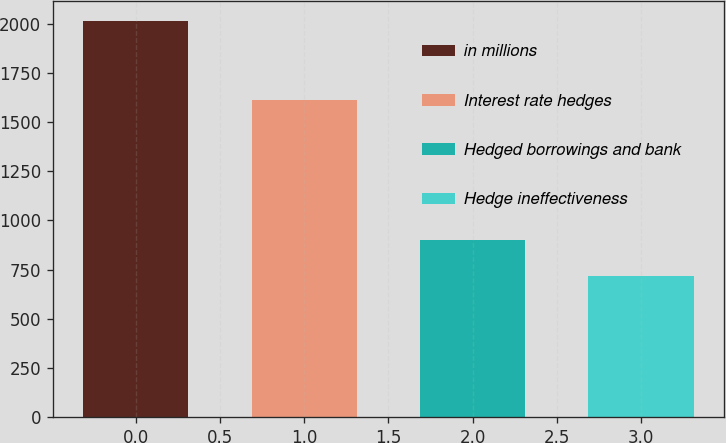Convert chart. <chart><loc_0><loc_0><loc_500><loc_500><bar_chart><fcel>in millions<fcel>Interest rate hedges<fcel>Hedged borrowings and bank<fcel>Hedge ineffectiveness<nl><fcel>2015<fcel>1613<fcel>898<fcel>715<nl></chart> 